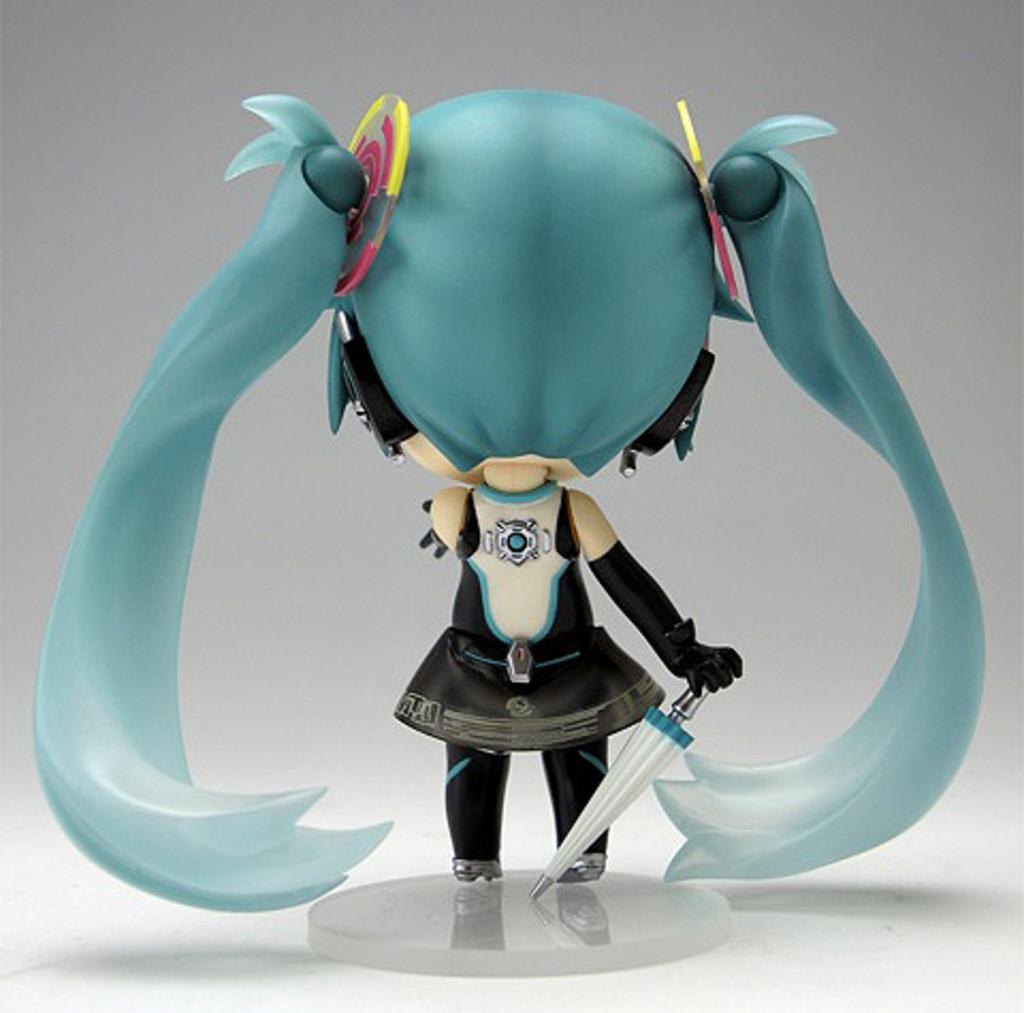What type of object is the main subject of the image? There is an animated toy in the image. Can you describe the animated toy in more detail? Unfortunately, the provided facts do not give any additional details about the animated toy. What other object is present in the image? There is a dagger present over a place in the image. Can you describe the position of the dagger in the image? The dagger is positioned over a place in the image, but the facts do not specify the exact location or orientation of the dagger. What type of business is being conducted in the image? There is no indication of any business activity in the image; it features an animated toy and a dagger. Can you tell me how many tanks are visible in the image? There are no tanks present in the image. 